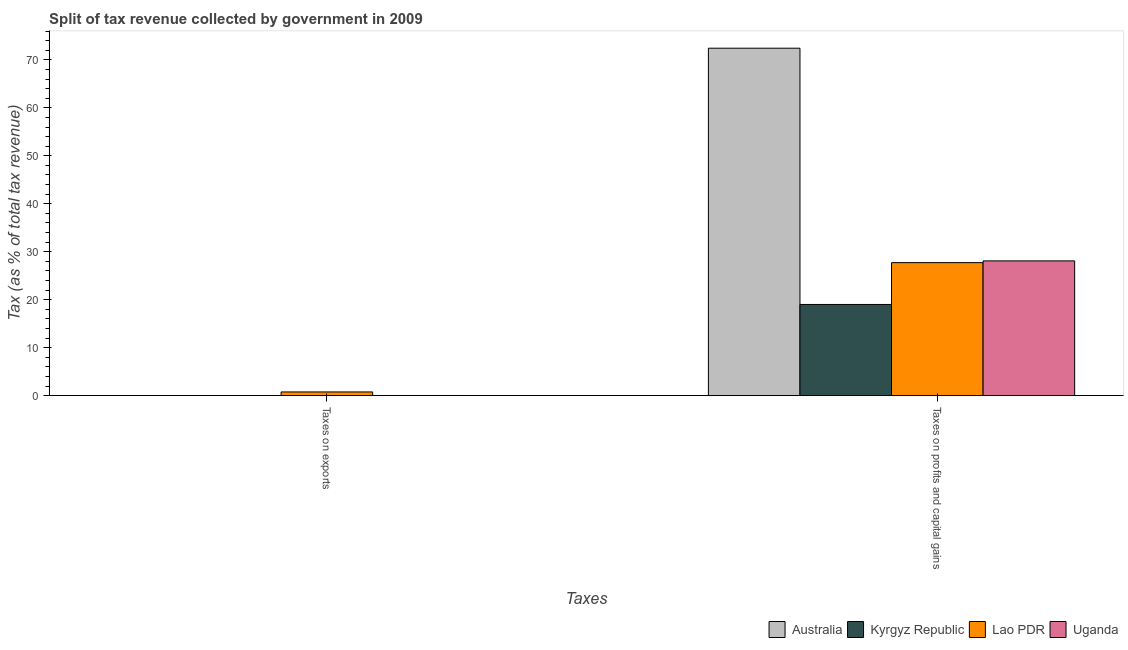How many different coloured bars are there?
Give a very brief answer. 4. Are the number of bars per tick equal to the number of legend labels?
Ensure brevity in your answer.  Yes. Are the number of bars on each tick of the X-axis equal?
Give a very brief answer. Yes. How many bars are there on the 2nd tick from the left?
Offer a terse response. 4. What is the label of the 1st group of bars from the left?
Provide a short and direct response. Taxes on exports. What is the percentage of revenue obtained from taxes on exports in Kyrgyz Republic?
Offer a terse response. 0.01. Across all countries, what is the maximum percentage of revenue obtained from taxes on profits and capital gains?
Ensure brevity in your answer.  72.43. Across all countries, what is the minimum percentage of revenue obtained from taxes on profits and capital gains?
Your answer should be very brief. 19.01. In which country was the percentage of revenue obtained from taxes on exports maximum?
Ensure brevity in your answer.  Lao PDR. What is the total percentage of revenue obtained from taxes on exports in the graph?
Keep it short and to the point. 0.82. What is the difference between the percentage of revenue obtained from taxes on profits and capital gains in Lao PDR and that in Uganda?
Give a very brief answer. -0.37. What is the difference between the percentage of revenue obtained from taxes on exports in Lao PDR and the percentage of revenue obtained from taxes on profits and capital gains in Uganda?
Your response must be concise. -27.32. What is the average percentage of revenue obtained from taxes on profits and capital gains per country?
Offer a very short reply. 36.82. What is the difference between the percentage of revenue obtained from taxes on exports and percentage of revenue obtained from taxes on profits and capital gains in Australia?
Your answer should be very brief. -72.43. What is the ratio of the percentage of revenue obtained from taxes on exports in Uganda to that in Kyrgyz Republic?
Provide a succinct answer. 2.64. What does the 1st bar from the left in Taxes on profits and capital gains represents?
Keep it short and to the point. Australia. What does the 2nd bar from the right in Taxes on exports represents?
Provide a short and direct response. Lao PDR. How many countries are there in the graph?
Provide a short and direct response. 4. Does the graph contain any zero values?
Your answer should be compact. No. How many legend labels are there?
Make the answer very short. 4. What is the title of the graph?
Your answer should be very brief. Split of tax revenue collected by government in 2009. What is the label or title of the X-axis?
Your answer should be very brief. Taxes. What is the label or title of the Y-axis?
Your response must be concise. Tax (as % of total tax revenue). What is the Tax (as % of total tax revenue) of Australia in Taxes on exports?
Ensure brevity in your answer.  0. What is the Tax (as % of total tax revenue) of Kyrgyz Republic in Taxes on exports?
Your response must be concise. 0.01. What is the Tax (as % of total tax revenue) of Lao PDR in Taxes on exports?
Your answer should be very brief. 0.77. What is the Tax (as % of total tax revenue) of Uganda in Taxes on exports?
Your response must be concise. 0.03. What is the Tax (as % of total tax revenue) in Australia in Taxes on profits and capital gains?
Offer a very short reply. 72.43. What is the Tax (as % of total tax revenue) in Kyrgyz Republic in Taxes on profits and capital gains?
Your response must be concise. 19.01. What is the Tax (as % of total tax revenue) in Lao PDR in Taxes on profits and capital gains?
Your answer should be compact. 27.72. What is the Tax (as % of total tax revenue) of Uganda in Taxes on profits and capital gains?
Give a very brief answer. 28.09. Across all Taxes, what is the maximum Tax (as % of total tax revenue) of Australia?
Provide a short and direct response. 72.43. Across all Taxes, what is the maximum Tax (as % of total tax revenue) of Kyrgyz Republic?
Offer a very short reply. 19.01. Across all Taxes, what is the maximum Tax (as % of total tax revenue) in Lao PDR?
Ensure brevity in your answer.  27.72. Across all Taxes, what is the maximum Tax (as % of total tax revenue) of Uganda?
Provide a succinct answer. 28.09. Across all Taxes, what is the minimum Tax (as % of total tax revenue) of Australia?
Give a very brief answer. 0. Across all Taxes, what is the minimum Tax (as % of total tax revenue) in Kyrgyz Republic?
Your response must be concise. 0.01. Across all Taxes, what is the minimum Tax (as % of total tax revenue) in Lao PDR?
Your response must be concise. 0.77. Across all Taxes, what is the minimum Tax (as % of total tax revenue) in Uganda?
Provide a short and direct response. 0.03. What is the total Tax (as % of total tax revenue) in Australia in the graph?
Give a very brief answer. 72.44. What is the total Tax (as % of total tax revenue) in Kyrgyz Republic in the graph?
Your response must be concise. 19.02. What is the total Tax (as % of total tax revenue) of Lao PDR in the graph?
Provide a succinct answer. 28.5. What is the total Tax (as % of total tax revenue) in Uganda in the graph?
Provide a short and direct response. 28.13. What is the difference between the Tax (as % of total tax revenue) of Australia in Taxes on exports and that in Taxes on profits and capital gains?
Ensure brevity in your answer.  -72.43. What is the difference between the Tax (as % of total tax revenue) in Kyrgyz Republic in Taxes on exports and that in Taxes on profits and capital gains?
Provide a succinct answer. -19. What is the difference between the Tax (as % of total tax revenue) in Lao PDR in Taxes on exports and that in Taxes on profits and capital gains?
Offer a terse response. -26.95. What is the difference between the Tax (as % of total tax revenue) of Uganda in Taxes on exports and that in Taxes on profits and capital gains?
Your answer should be very brief. -28.06. What is the difference between the Tax (as % of total tax revenue) in Australia in Taxes on exports and the Tax (as % of total tax revenue) in Kyrgyz Republic in Taxes on profits and capital gains?
Provide a succinct answer. -19.01. What is the difference between the Tax (as % of total tax revenue) in Australia in Taxes on exports and the Tax (as % of total tax revenue) in Lao PDR in Taxes on profits and capital gains?
Provide a succinct answer. -27.72. What is the difference between the Tax (as % of total tax revenue) in Australia in Taxes on exports and the Tax (as % of total tax revenue) in Uganda in Taxes on profits and capital gains?
Keep it short and to the point. -28.09. What is the difference between the Tax (as % of total tax revenue) in Kyrgyz Republic in Taxes on exports and the Tax (as % of total tax revenue) in Lao PDR in Taxes on profits and capital gains?
Give a very brief answer. -27.71. What is the difference between the Tax (as % of total tax revenue) in Kyrgyz Republic in Taxes on exports and the Tax (as % of total tax revenue) in Uganda in Taxes on profits and capital gains?
Offer a very short reply. -28.08. What is the difference between the Tax (as % of total tax revenue) in Lao PDR in Taxes on exports and the Tax (as % of total tax revenue) in Uganda in Taxes on profits and capital gains?
Your answer should be compact. -27.32. What is the average Tax (as % of total tax revenue) of Australia per Taxes?
Provide a succinct answer. 36.22. What is the average Tax (as % of total tax revenue) in Kyrgyz Republic per Taxes?
Offer a terse response. 9.51. What is the average Tax (as % of total tax revenue) of Lao PDR per Taxes?
Ensure brevity in your answer.  14.25. What is the average Tax (as % of total tax revenue) in Uganda per Taxes?
Your answer should be compact. 14.06. What is the difference between the Tax (as % of total tax revenue) of Australia and Tax (as % of total tax revenue) of Kyrgyz Republic in Taxes on exports?
Your answer should be compact. -0.01. What is the difference between the Tax (as % of total tax revenue) of Australia and Tax (as % of total tax revenue) of Lao PDR in Taxes on exports?
Your response must be concise. -0.77. What is the difference between the Tax (as % of total tax revenue) of Australia and Tax (as % of total tax revenue) of Uganda in Taxes on exports?
Your answer should be compact. -0.03. What is the difference between the Tax (as % of total tax revenue) of Kyrgyz Republic and Tax (as % of total tax revenue) of Lao PDR in Taxes on exports?
Provide a short and direct response. -0.76. What is the difference between the Tax (as % of total tax revenue) in Kyrgyz Republic and Tax (as % of total tax revenue) in Uganda in Taxes on exports?
Provide a short and direct response. -0.02. What is the difference between the Tax (as % of total tax revenue) of Lao PDR and Tax (as % of total tax revenue) of Uganda in Taxes on exports?
Your answer should be very brief. 0.74. What is the difference between the Tax (as % of total tax revenue) in Australia and Tax (as % of total tax revenue) in Kyrgyz Republic in Taxes on profits and capital gains?
Provide a short and direct response. 53.42. What is the difference between the Tax (as % of total tax revenue) in Australia and Tax (as % of total tax revenue) in Lao PDR in Taxes on profits and capital gains?
Provide a succinct answer. 44.71. What is the difference between the Tax (as % of total tax revenue) in Australia and Tax (as % of total tax revenue) in Uganda in Taxes on profits and capital gains?
Your answer should be compact. 44.34. What is the difference between the Tax (as % of total tax revenue) of Kyrgyz Republic and Tax (as % of total tax revenue) of Lao PDR in Taxes on profits and capital gains?
Provide a short and direct response. -8.71. What is the difference between the Tax (as % of total tax revenue) of Kyrgyz Republic and Tax (as % of total tax revenue) of Uganda in Taxes on profits and capital gains?
Keep it short and to the point. -9.08. What is the difference between the Tax (as % of total tax revenue) of Lao PDR and Tax (as % of total tax revenue) of Uganda in Taxes on profits and capital gains?
Your answer should be very brief. -0.37. What is the ratio of the Tax (as % of total tax revenue) in Kyrgyz Republic in Taxes on exports to that in Taxes on profits and capital gains?
Ensure brevity in your answer.  0. What is the ratio of the Tax (as % of total tax revenue) of Lao PDR in Taxes on exports to that in Taxes on profits and capital gains?
Your answer should be compact. 0.03. What is the ratio of the Tax (as % of total tax revenue) of Uganda in Taxes on exports to that in Taxes on profits and capital gains?
Offer a very short reply. 0. What is the difference between the highest and the second highest Tax (as % of total tax revenue) in Australia?
Offer a very short reply. 72.43. What is the difference between the highest and the second highest Tax (as % of total tax revenue) in Kyrgyz Republic?
Your response must be concise. 19. What is the difference between the highest and the second highest Tax (as % of total tax revenue) of Lao PDR?
Offer a very short reply. 26.95. What is the difference between the highest and the second highest Tax (as % of total tax revenue) of Uganda?
Provide a succinct answer. 28.06. What is the difference between the highest and the lowest Tax (as % of total tax revenue) of Australia?
Provide a short and direct response. 72.43. What is the difference between the highest and the lowest Tax (as % of total tax revenue) in Kyrgyz Republic?
Your answer should be very brief. 19. What is the difference between the highest and the lowest Tax (as % of total tax revenue) of Lao PDR?
Provide a succinct answer. 26.95. What is the difference between the highest and the lowest Tax (as % of total tax revenue) of Uganda?
Make the answer very short. 28.06. 